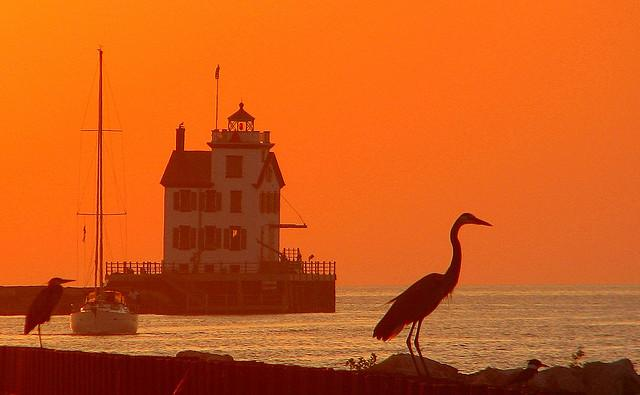Which animal is most similar to the animal on the right? pelican 